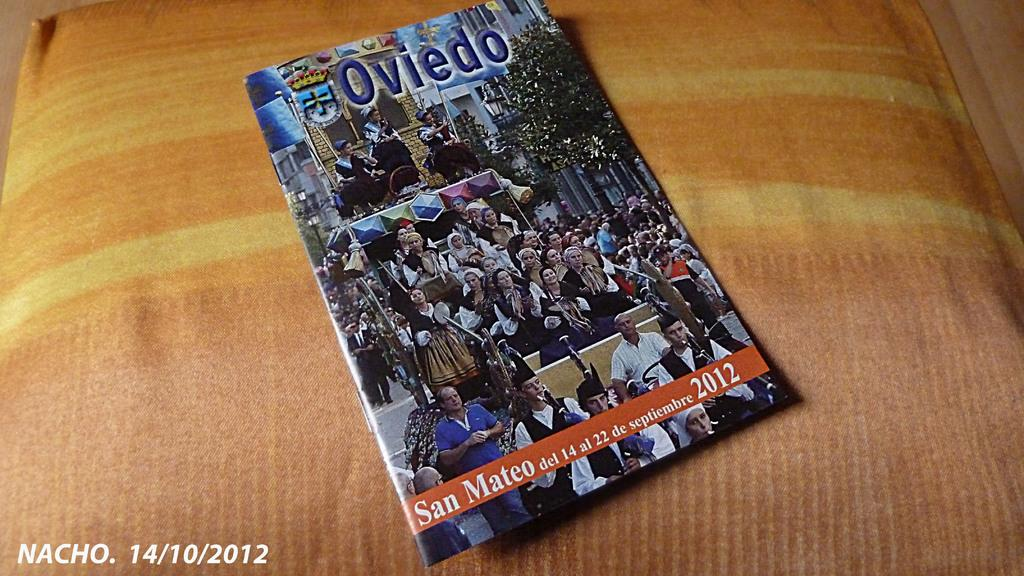Provide a one-sentence caption for the provided image. A 2012 issue of the magazine Oviedo is displayed on a cushion. 